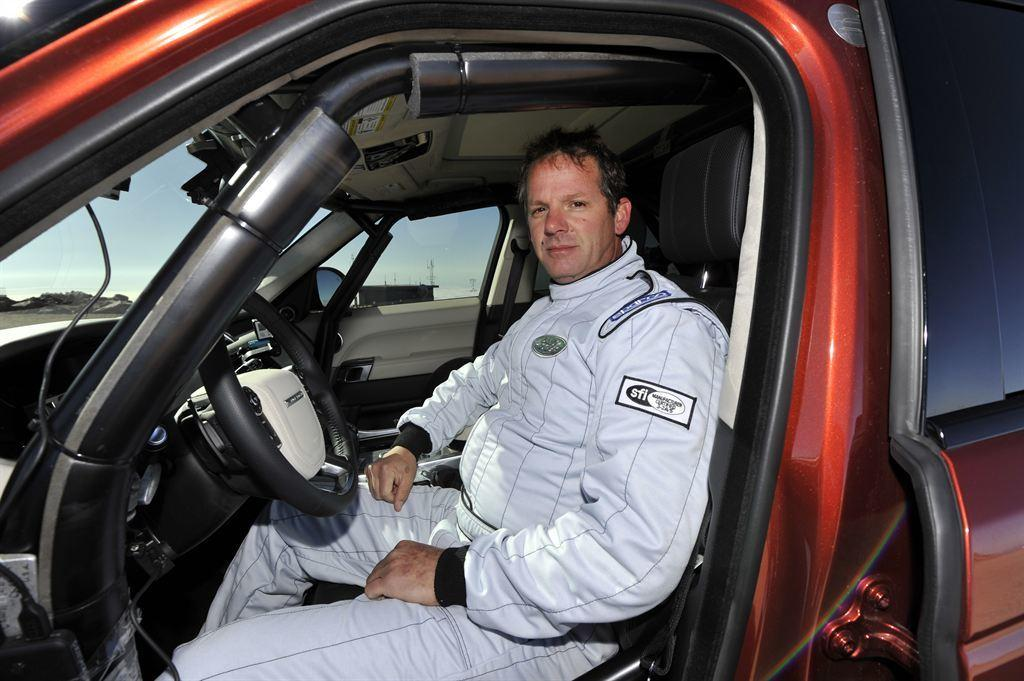Who is present in the image? There is a man in the image. What is the man doing in the image? The man is sitting inside a vehicle. What can be seen through the glass of the vehicle? The sky is visible through the glass of the vehicle. What type of light does the goose emit in the image? There is no goose present in the image, so it cannot emit any light. 